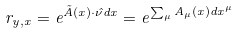<formula> <loc_0><loc_0><loc_500><loc_500>r _ { y , x } = e ^ { \vec { A } ( x ) \cdot \hat { \nu } d x } = e ^ { \sum _ { \mu } A _ { \mu } ( x ) d x ^ { \mu } }</formula> 